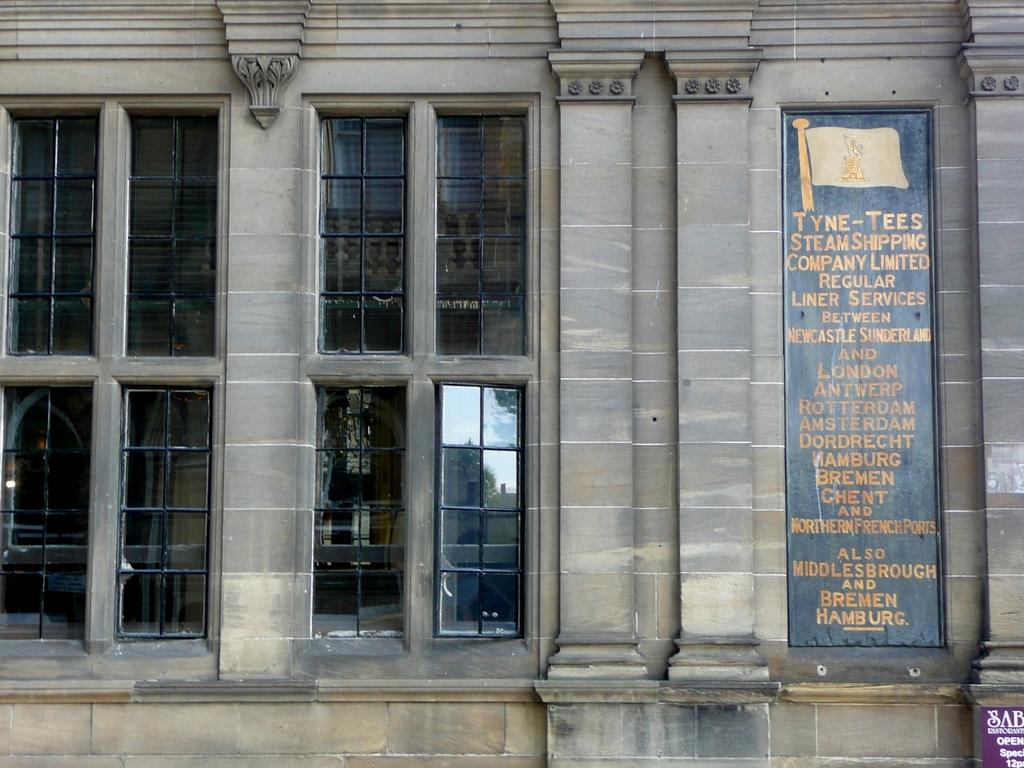What is the main structure in the center of the image? There is a building in the center of the image. What can be seen on the right side of the image? There is a board on the right side of the image. What type of windows are present on the left side of the image? There are glass windows on the left side of the image. How many pizzas are being bitten in the image? There are no pizzas present in the image, so it is not possible to determine how many are being bitten. 